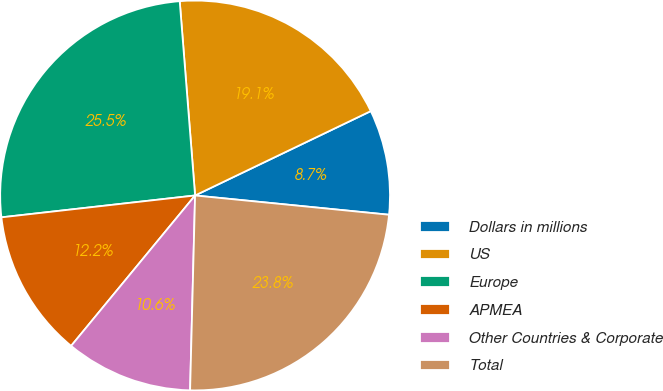<chart> <loc_0><loc_0><loc_500><loc_500><pie_chart><fcel>Dollars in millions<fcel>US<fcel>Europe<fcel>APMEA<fcel>Other Countries & Corporate<fcel>Total<nl><fcel>8.7%<fcel>19.13%<fcel>25.53%<fcel>12.24%<fcel>10.56%<fcel>23.83%<nl></chart> 